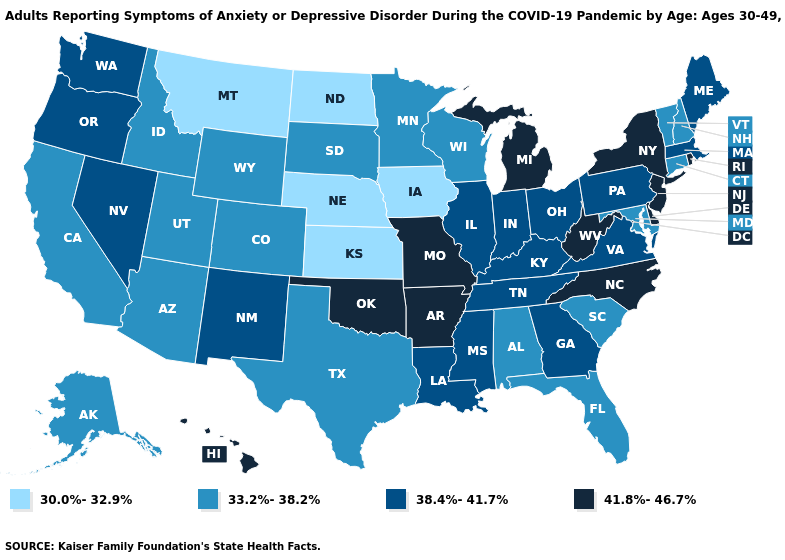Which states have the highest value in the USA?
Short answer required. Arkansas, Delaware, Hawaii, Michigan, Missouri, New Jersey, New York, North Carolina, Oklahoma, Rhode Island, West Virginia. What is the value of Nebraska?
Answer briefly. 30.0%-32.9%. What is the value of Louisiana?
Quick response, please. 38.4%-41.7%. Name the states that have a value in the range 33.2%-38.2%?
Give a very brief answer. Alabama, Alaska, Arizona, California, Colorado, Connecticut, Florida, Idaho, Maryland, Minnesota, New Hampshire, South Carolina, South Dakota, Texas, Utah, Vermont, Wisconsin, Wyoming. Does the map have missing data?
Short answer required. No. Name the states that have a value in the range 33.2%-38.2%?
Quick response, please. Alabama, Alaska, Arizona, California, Colorado, Connecticut, Florida, Idaho, Maryland, Minnesota, New Hampshire, South Carolina, South Dakota, Texas, Utah, Vermont, Wisconsin, Wyoming. Name the states that have a value in the range 33.2%-38.2%?
Concise answer only. Alabama, Alaska, Arizona, California, Colorado, Connecticut, Florida, Idaho, Maryland, Minnesota, New Hampshire, South Carolina, South Dakota, Texas, Utah, Vermont, Wisconsin, Wyoming. Does Virginia have the highest value in the USA?
Write a very short answer. No. Does New Jersey have the lowest value in the Northeast?
Quick response, please. No. What is the value of Arizona?
Be succinct. 33.2%-38.2%. Does Kansas have the lowest value in the USA?
Short answer required. Yes. Which states hav the highest value in the South?
Keep it brief. Arkansas, Delaware, North Carolina, Oklahoma, West Virginia. Among the states that border Oregon , which have the highest value?
Give a very brief answer. Nevada, Washington. Among the states that border Mississippi , does Arkansas have the lowest value?
Give a very brief answer. No. Name the states that have a value in the range 33.2%-38.2%?
Short answer required. Alabama, Alaska, Arizona, California, Colorado, Connecticut, Florida, Idaho, Maryland, Minnesota, New Hampshire, South Carolina, South Dakota, Texas, Utah, Vermont, Wisconsin, Wyoming. 